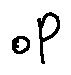Convert formula to latex. <formula><loc_0><loc_0><loc_500><loc_500>o P</formula> 